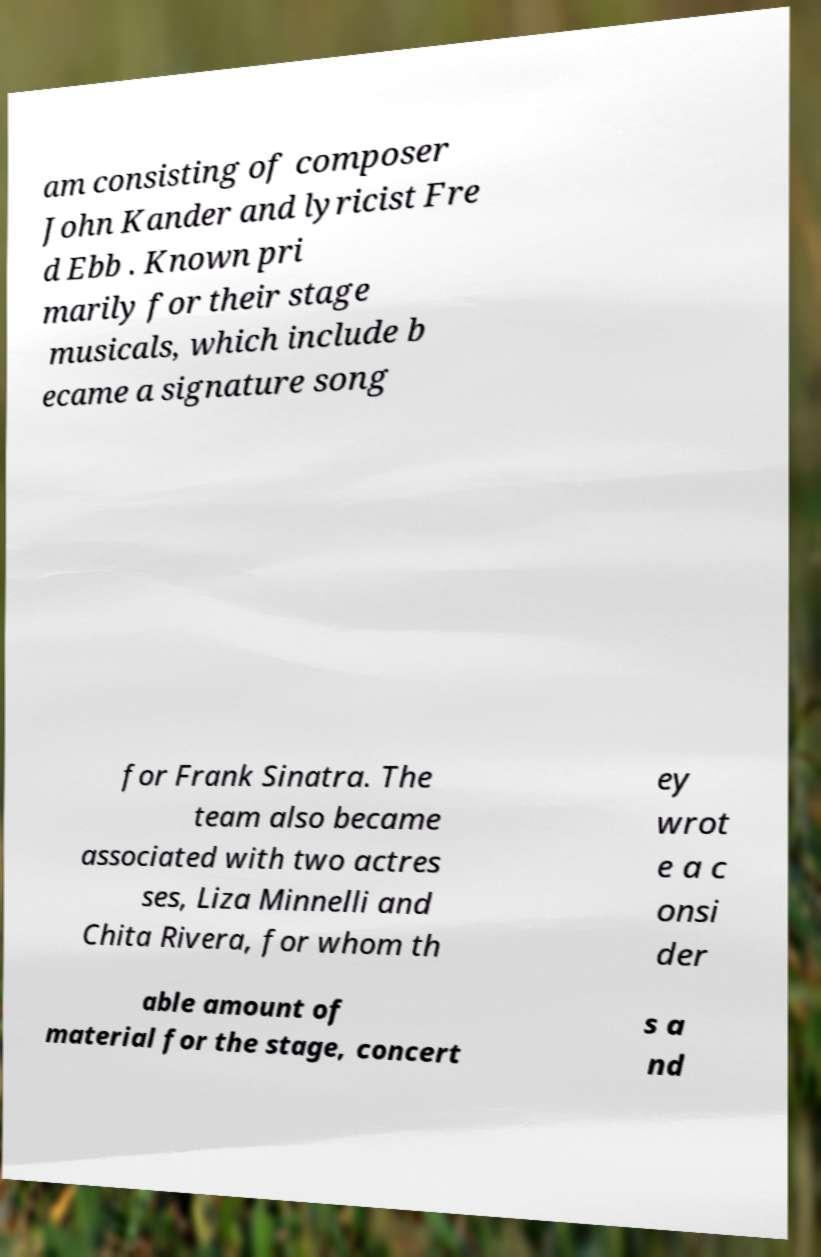Can you accurately transcribe the text from the provided image for me? am consisting of composer John Kander and lyricist Fre d Ebb . Known pri marily for their stage musicals, which include b ecame a signature song for Frank Sinatra. The team also became associated with two actres ses, Liza Minnelli and Chita Rivera, for whom th ey wrot e a c onsi der able amount of material for the stage, concert s a nd 